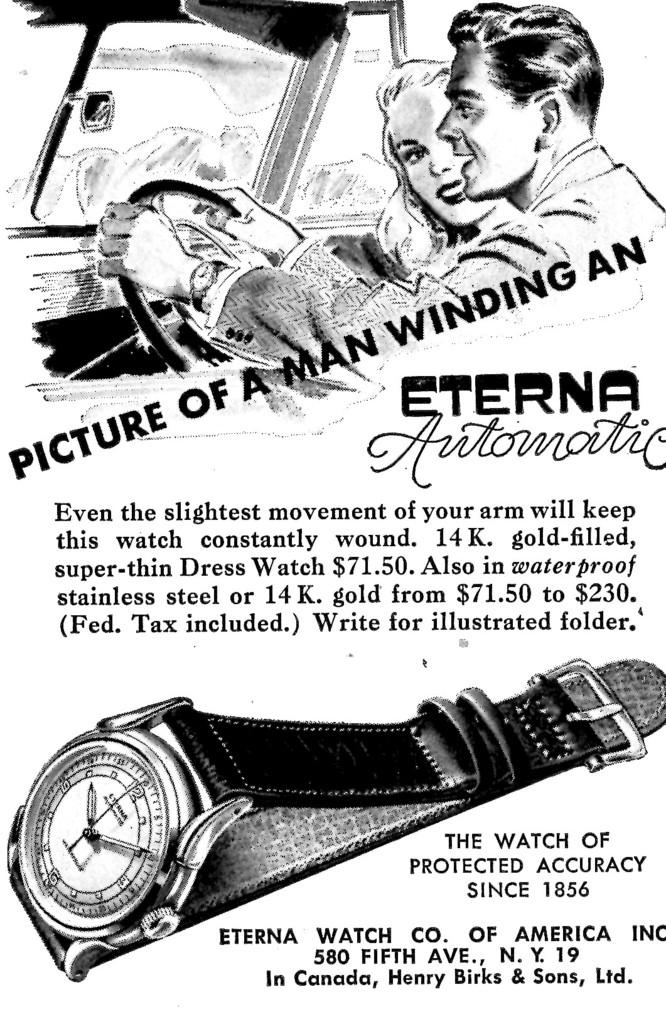<image>
Summarize the visual content of the image. A vintage ad for Eterna Automatic wrist watches. 